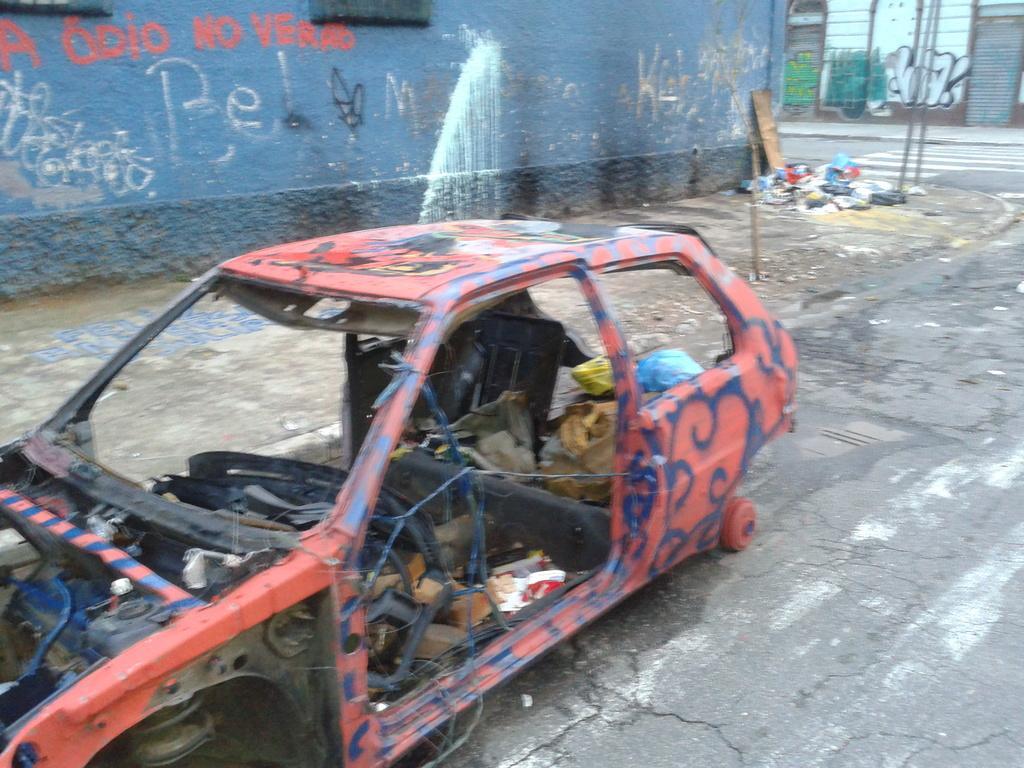Describe this image in one or two sentences. In this image we can see a crashed car. In the background there is a wall and we can see a text on the wall. At the bottom there is a road. In the background there are poles and a building. 